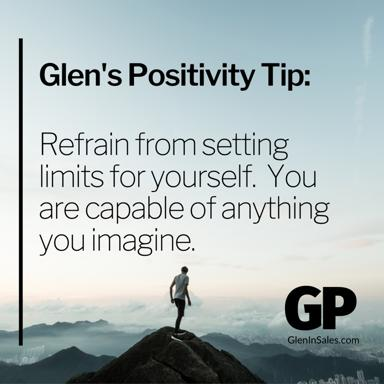What could be the symbolism of the clouds surrounding the mountain’s peak in this image? The clouds surrounding the mountain’s peak could symbolize the uncertainty and obscurity often associated with pursuing high, seemingly unreachable goals. Their presence accentuates the man's achievement, representing the clarity and success found when one surpasses these common barriers of doubt and fear, aligning with Glen’s message of transcending self-imposed limits. 